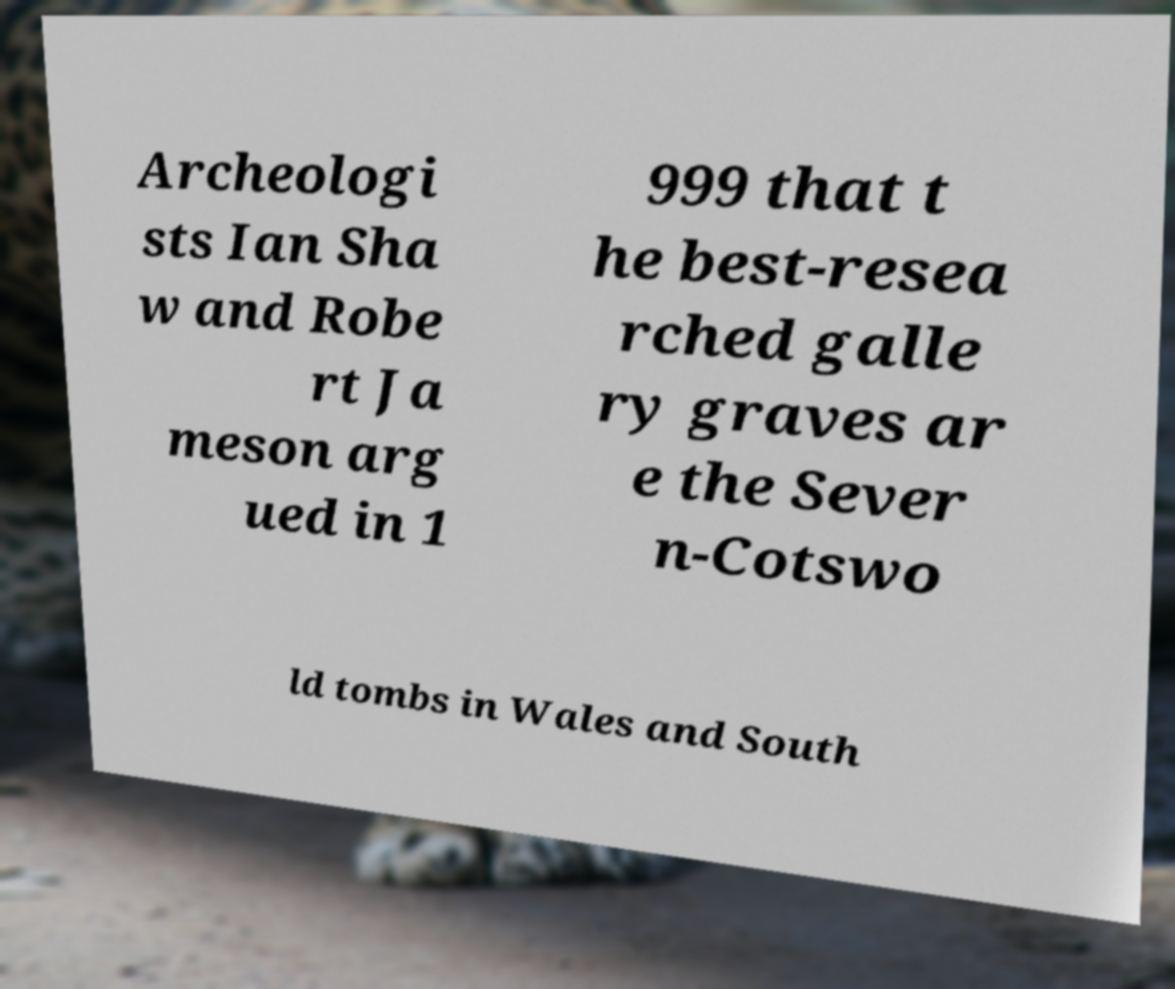Could you assist in decoding the text presented in this image and type it out clearly? Archeologi sts Ian Sha w and Robe rt Ja meson arg ued in 1 999 that t he best-resea rched galle ry graves ar e the Sever n-Cotswo ld tombs in Wales and South 